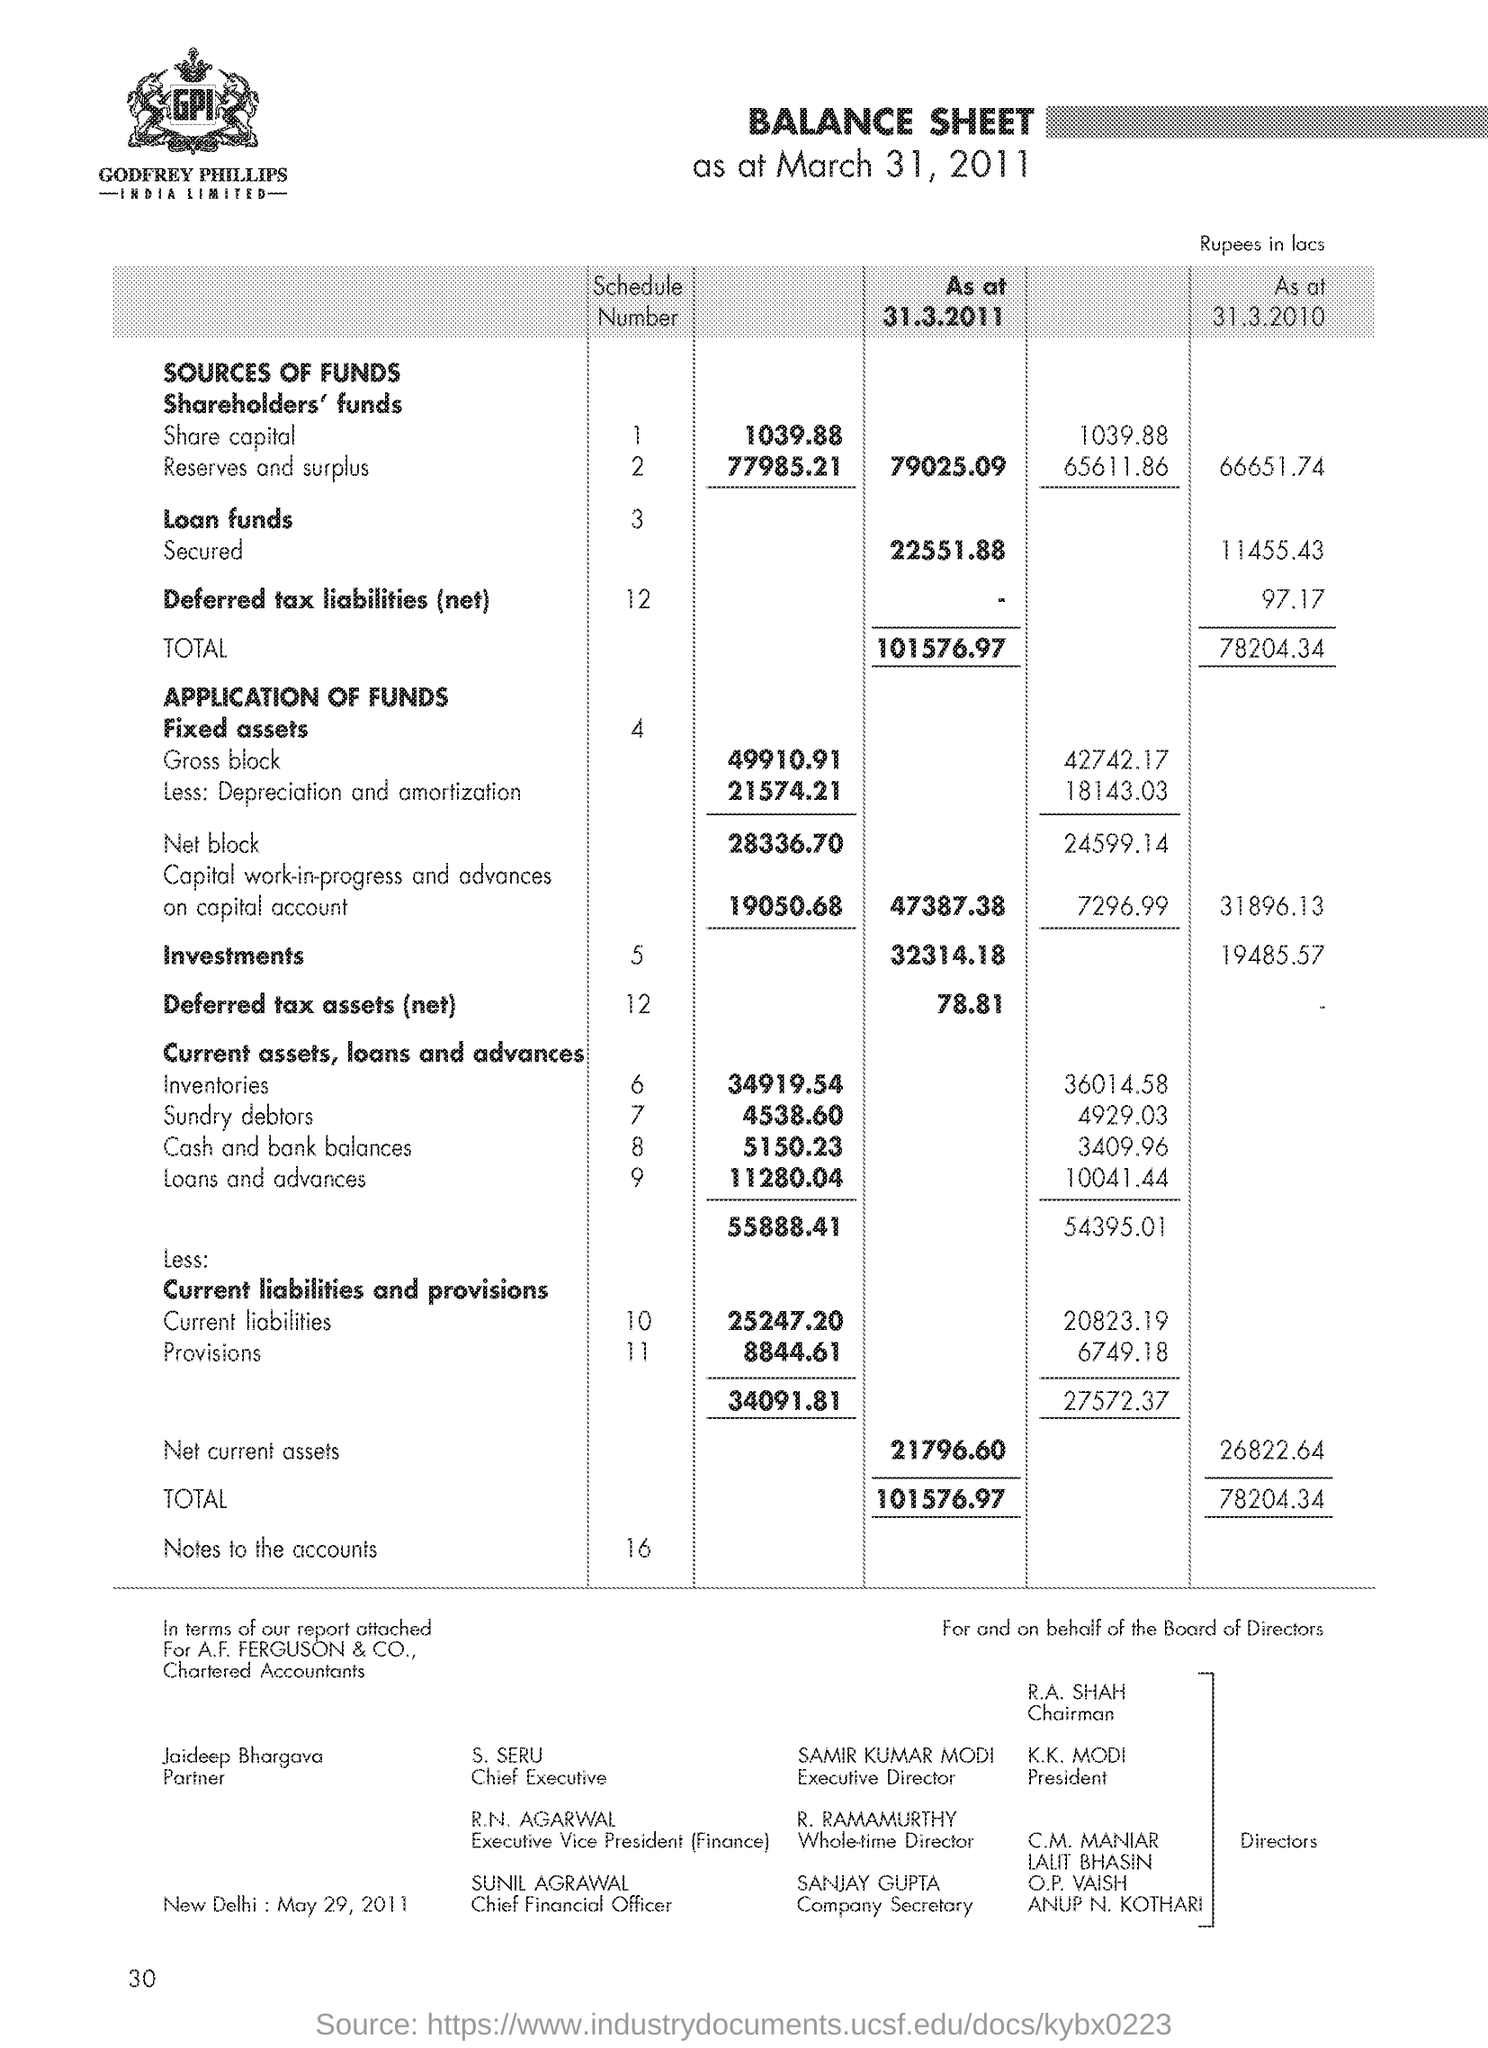How much is the Investments as at 31.3.2010 ?
Offer a terse response. 19485.57. How much is the current liabilities as at 31.3.2011 ?
Your answer should be compact. 25247.20. How much is the provisions as at 31.3.2011 ?
Offer a very short reply. 8844.61. Who is the Chief Financial Officer ?
Provide a succinct answer. Sunil Agrawal. Who is the Whole-time Director ?
Keep it short and to the point. R. Ramamurthy. What is the net current assets as at 31.3.2011 ?
Your answer should be compact. 21796.60. 